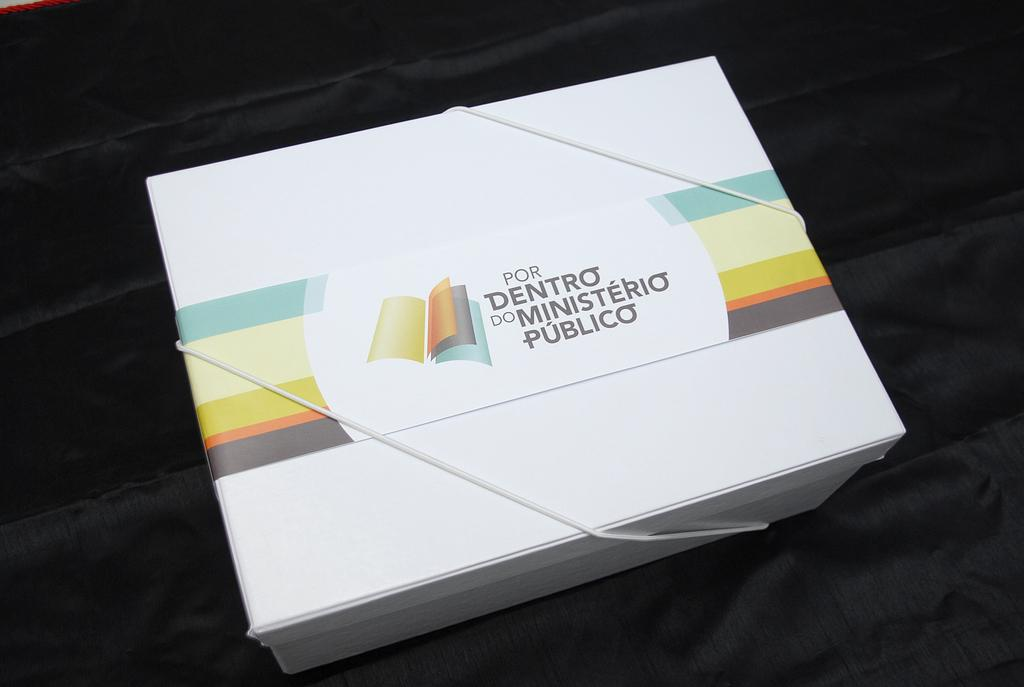<image>
Present a compact description of the photo's key features. A white package with a label that says Por Dentro Do minsterio Publico 